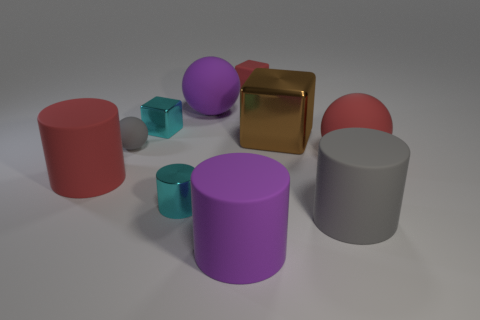Subtract 1 cylinders. How many cylinders are left? 3 Subtract all big spheres. How many spheres are left? 1 Subtract all green cylinders. Subtract all purple balls. How many cylinders are left? 4 Subtract all balls. How many objects are left? 7 Subtract 0 blue blocks. How many objects are left? 10 Subtract all small red objects. Subtract all red rubber cylinders. How many objects are left? 8 Add 8 large shiny blocks. How many large shiny blocks are left? 9 Add 1 small cubes. How many small cubes exist? 3 